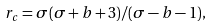<formula> <loc_0><loc_0><loc_500><loc_500>r _ { c } = \sigma ( \sigma + b + 3 ) / ( \sigma - b - 1 ) ,</formula> 